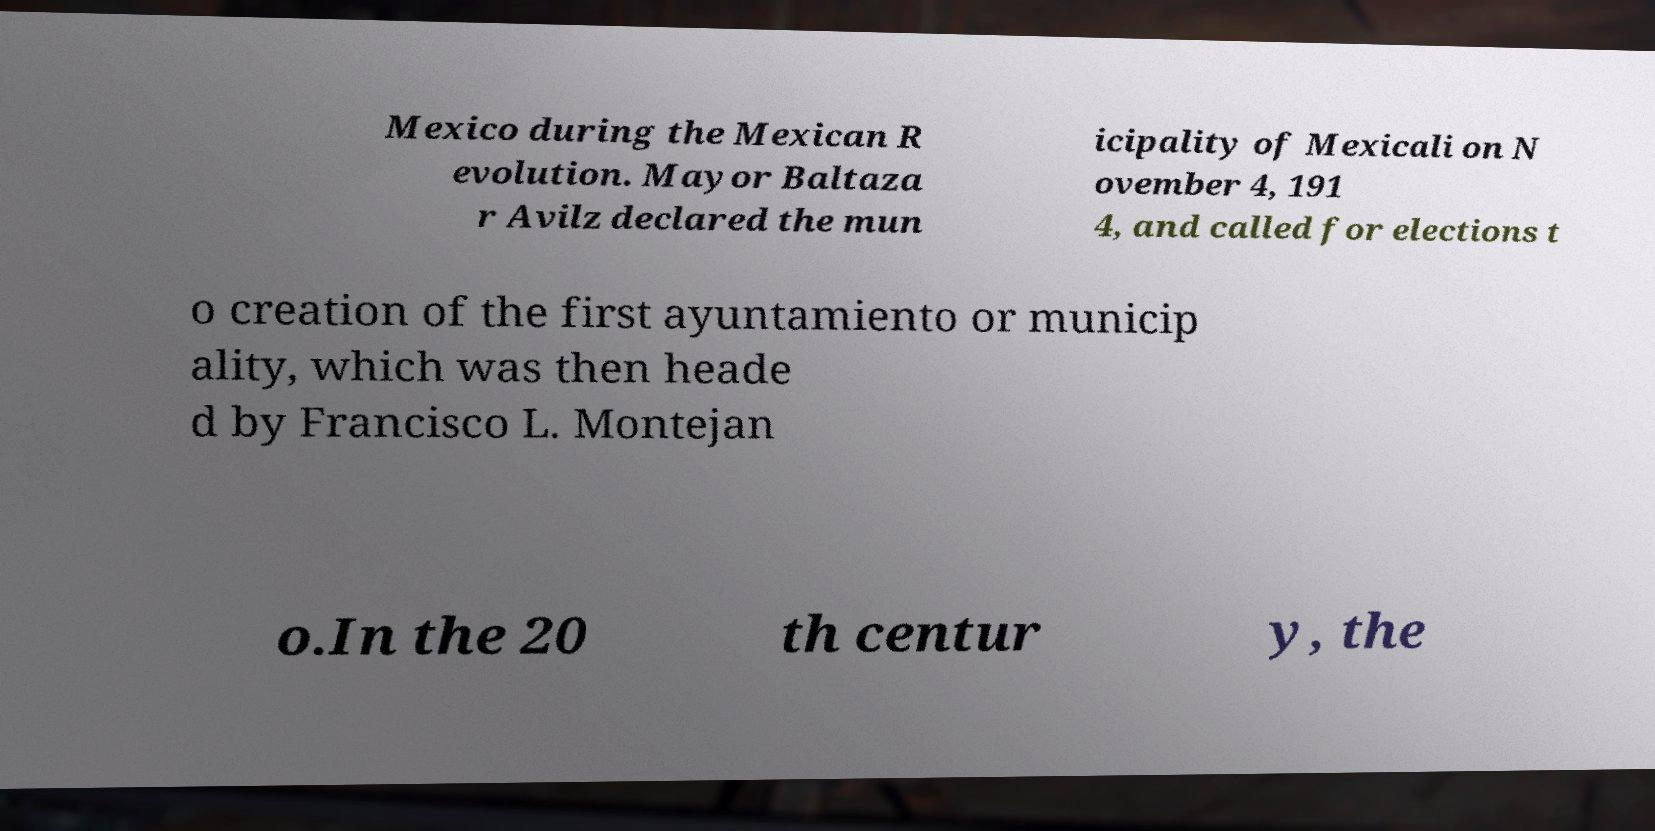What messages or text are displayed in this image? I need them in a readable, typed format. Mexico during the Mexican R evolution. Mayor Baltaza r Avilz declared the mun icipality of Mexicali on N ovember 4, 191 4, and called for elections t o creation of the first ayuntamiento or municip ality, which was then heade d by Francisco L. Montejan o.In the 20 th centur y, the 